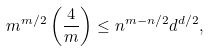<formula> <loc_0><loc_0><loc_500><loc_500>m ^ { m / 2 } \left ( \frac { 4 } { m } \right ) \leq n ^ { m - n / 2 } d ^ { d / 2 } ,</formula> 